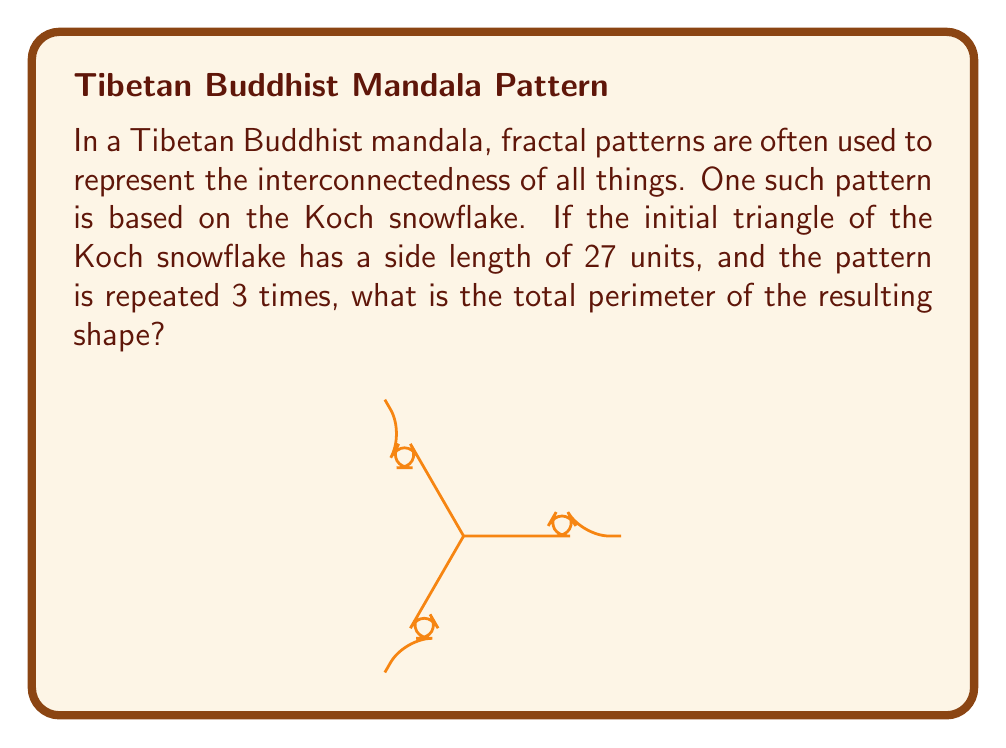Could you help me with this problem? Let's approach this step-by-step:

1) The Koch snowflake is created by repeatedly dividing each side of a triangle into thirds and replacing the middle third with an equilateral triangle.

2) Initial perimeter:
   $P_0 = 3 * 27 = 81$ units

3) After the first iteration:
   Each side is replaced by 4 segments, each 1/3 of the original length.
   New length of each side: $27 * (4/3) = 36$ units
   $P_1 = 3 * 36 = 108$ units

4) We can generalize this. After each iteration, the perimeter is multiplied by 4/3:
   $P_n = P_{n-1} * (4/3)$

5) Therefore, after 3 iterations:
   $P_3 = 81 * (4/3)^3$

6) Let's calculate this:
   $P_3 = 81 * (4/3)^3$
   $= 81 * (64/27)$
   $= 81 * 64 / 27$
   $= 5184 / 27$
   $= 192$ units

Thus, after 3 iterations, the perimeter of the Koch snowflake will be 192 units.
Answer: 192 units 